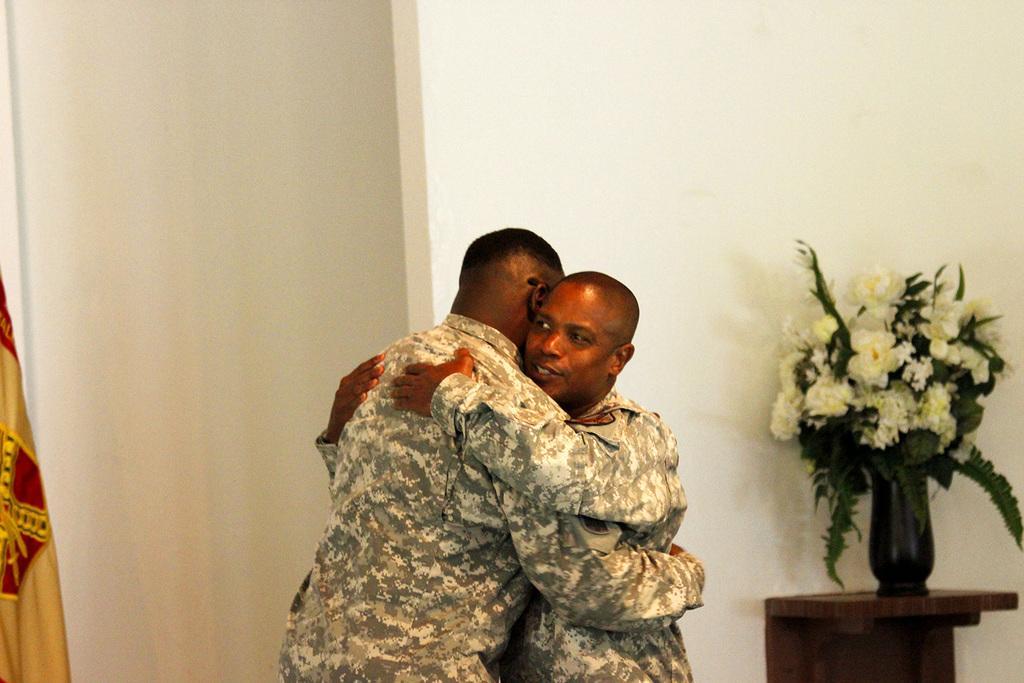Please provide a concise description of this image. In this image I can see two men are standing and I can see both of them are wearing uniforms. In the background I can see a rack and on it I can see white color flowers in a vase. I can also see a golden and red color flag over here. 